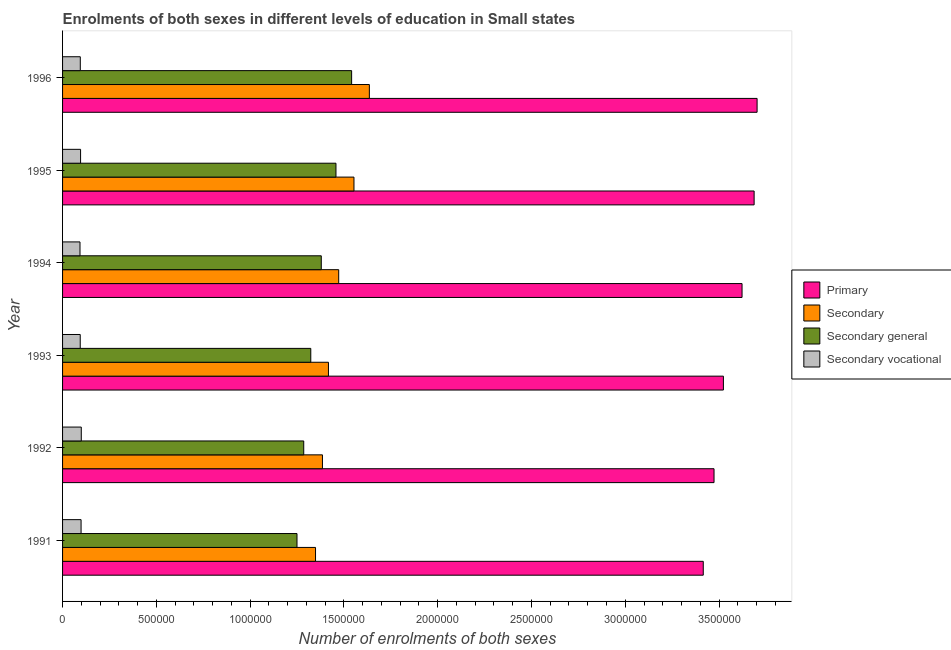How many groups of bars are there?
Keep it short and to the point. 6. How many bars are there on the 6th tick from the bottom?
Offer a very short reply. 4. What is the label of the 6th group of bars from the top?
Ensure brevity in your answer.  1991. What is the number of enrolments in secondary education in 1994?
Provide a short and direct response. 1.47e+06. Across all years, what is the maximum number of enrolments in secondary vocational education?
Provide a succinct answer. 9.98e+04. Across all years, what is the minimum number of enrolments in secondary vocational education?
Provide a short and direct response. 9.29e+04. In which year was the number of enrolments in secondary education maximum?
Keep it short and to the point. 1996. In which year was the number of enrolments in secondary vocational education minimum?
Your answer should be very brief. 1994. What is the total number of enrolments in secondary general education in the graph?
Offer a terse response. 8.24e+06. What is the difference between the number of enrolments in secondary vocational education in 1991 and that in 1992?
Keep it short and to the point. -1069.15. What is the difference between the number of enrolments in secondary general education in 1991 and the number of enrolments in secondary vocational education in 1996?
Give a very brief answer. 1.16e+06. What is the average number of enrolments in secondary education per year?
Ensure brevity in your answer.  1.47e+06. In the year 1994, what is the difference between the number of enrolments in secondary education and number of enrolments in secondary general education?
Offer a terse response. 9.29e+04. What is the ratio of the number of enrolments in secondary education in 1993 to that in 1994?
Offer a very short reply. 0.96. What is the difference between the highest and the second highest number of enrolments in primary education?
Make the answer very short. 1.58e+04. What is the difference between the highest and the lowest number of enrolments in secondary general education?
Your response must be concise. 2.91e+05. What does the 2nd bar from the top in 1991 represents?
Give a very brief answer. Secondary general. What does the 2nd bar from the bottom in 1996 represents?
Provide a short and direct response. Secondary. Is it the case that in every year, the sum of the number of enrolments in primary education and number of enrolments in secondary education is greater than the number of enrolments in secondary general education?
Provide a succinct answer. Yes. How many bars are there?
Provide a short and direct response. 24. How many years are there in the graph?
Provide a succinct answer. 6. Are the values on the major ticks of X-axis written in scientific E-notation?
Offer a very short reply. No. Does the graph contain grids?
Your answer should be very brief. No. Where does the legend appear in the graph?
Offer a terse response. Center right. How many legend labels are there?
Make the answer very short. 4. What is the title of the graph?
Provide a short and direct response. Enrolments of both sexes in different levels of education in Small states. Does "Primary schools" appear as one of the legend labels in the graph?
Offer a very short reply. No. What is the label or title of the X-axis?
Offer a very short reply. Number of enrolments of both sexes. What is the Number of enrolments of both sexes of Primary in 1991?
Ensure brevity in your answer.  3.42e+06. What is the Number of enrolments of both sexes of Secondary in 1991?
Give a very brief answer. 1.35e+06. What is the Number of enrolments of both sexes in Secondary general in 1991?
Keep it short and to the point. 1.25e+06. What is the Number of enrolments of both sexes in Secondary vocational in 1991?
Provide a succinct answer. 9.87e+04. What is the Number of enrolments of both sexes of Primary in 1992?
Your answer should be compact. 3.47e+06. What is the Number of enrolments of both sexes in Secondary in 1992?
Offer a terse response. 1.39e+06. What is the Number of enrolments of both sexes in Secondary general in 1992?
Your response must be concise. 1.29e+06. What is the Number of enrolments of both sexes in Secondary vocational in 1992?
Your answer should be compact. 9.98e+04. What is the Number of enrolments of both sexes of Primary in 1993?
Provide a succinct answer. 3.52e+06. What is the Number of enrolments of both sexes in Secondary in 1993?
Your answer should be compact. 1.42e+06. What is the Number of enrolments of both sexes of Secondary general in 1993?
Give a very brief answer. 1.32e+06. What is the Number of enrolments of both sexes in Secondary vocational in 1993?
Offer a very short reply. 9.42e+04. What is the Number of enrolments of both sexes in Primary in 1994?
Keep it short and to the point. 3.62e+06. What is the Number of enrolments of both sexes in Secondary in 1994?
Offer a terse response. 1.47e+06. What is the Number of enrolments of both sexes in Secondary general in 1994?
Provide a succinct answer. 1.38e+06. What is the Number of enrolments of both sexes in Secondary vocational in 1994?
Offer a terse response. 9.29e+04. What is the Number of enrolments of both sexes in Primary in 1995?
Give a very brief answer. 3.69e+06. What is the Number of enrolments of both sexes in Secondary in 1995?
Provide a short and direct response. 1.55e+06. What is the Number of enrolments of both sexes in Secondary general in 1995?
Make the answer very short. 1.46e+06. What is the Number of enrolments of both sexes in Secondary vocational in 1995?
Your answer should be very brief. 9.60e+04. What is the Number of enrolments of both sexes in Primary in 1996?
Offer a terse response. 3.70e+06. What is the Number of enrolments of both sexes in Secondary in 1996?
Give a very brief answer. 1.64e+06. What is the Number of enrolments of both sexes in Secondary general in 1996?
Ensure brevity in your answer.  1.54e+06. What is the Number of enrolments of both sexes of Secondary vocational in 1996?
Offer a very short reply. 9.46e+04. Across all years, what is the maximum Number of enrolments of both sexes of Primary?
Offer a very short reply. 3.70e+06. Across all years, what is the maximum Number of enrolments of both sexes in Secondary?
Your answer should be very brief. 1.64e+06. Across all years, what is the maximum Number of enrolments of both sexes in Secondary general?
Provide a short and direct response. 1.54e+06. Across all years, what is the maximum Number of enrolments of both sexes in Secondary vocational?
Your answer should be compact. 9.98e+04. Across all years, what is the minimum Number of enrolments of both sexes of Primary?
Your answer should be compact. 3.42e+06. Across all years, what is the minimum Number of enrolments of both sexes in Secondary?
Make the answer very short. 1.35e+06. Across all years, what is the minimum Number of enrolments of both sexes in Secondary general?
Ensure brevity in your answer.  1.25e+06. Across all years, what is the minimum Number of enrolments of both sexes of Secondary vocational?
Offer a very short reply. 9.29e+04. What is the total Number of enrolments of both sexes of Primary in the graph?
Keep it short and to the point. 2.14e+07. What is the total Number of enrolments of both sexes in Secondary in the graph?
Provide a short and direct response. 8.81e+06. What is the total Number of enrolments of both sexes in Secondary general in the graph?
Your response must be concise. 8.24e+06. What is the total Number of enrolments of both sexes of Secondary vocational in the graph?
Offer a very short reply. 5.76e+05. What is the difference between the Number of enrolments of both sexes of Primary in 1991 and that in 1992?
Provide a succinct answer. -5.74e+04. What is the difference between the Number of enrolments of both sexes of Secondary in 1991 and that in 1992?
Make the answer very short. -3.69e+04. What is the difference between the Number of enrolments of both sexes in Secondary general in 1991 and that in 1992?
Offer a terse response. -3.58e+04. What is the difference between the Number of enrolments of both sexes in Secondary vocational in 1991 and that in 1992?
Offer a very short reply. -1069.15. What is the difference between the Number of enrolments of both sexes in Primary in 1991 and that in 1993?
Offer a terse response. -1.07e+05. What is the difference between the Number of enrolments of both sexes of Secondary in 1991 and that in 1993?
Make the answer very short. -6.90e+04. What is the difference between the Number of enrolments of both sexes of Secondary general in 1991 and that in 1993?
Offer a very short reply. -7.35e+04. What is the difference between the Number of enrolments of both sexes in Secondary vocational in 1991 and that in 1993?
Offer a very short reply. 4531.68. What is the difference between the Number of enrolments of both sexes in Primary in 1991 and that in 1994?
Offer a terse response. -2.07e+05. What is the difference between the Number of enrolments of both sexes of Secondary in 1991 and that in 1994?
Your answer should be compact. -1.24e+05. What is the difference between the Number of enrolments of both sexes of Secondary general in 1991 and that in 1994?
Your answer should be very brief. -1.29e+05. What is the difference between the Number of enrolments of both sexes in Secondary vocational in 1991 and that in 1994?
Offer a terse response. 5820.7. What is the difference between the Number of enrolments of both sexes in Primary in 1991 and that in 1995?
Give a very brief answer. -2.71e+05. What is the difference between the Number of enrolments of both sexes of Secondary in 1991 and that in 1995?
Your response must be concise. -2.05e+05. What is the difference between the Number of enrolments of both sexes of Secondary general in 1991 and that in 1995?
Your answer should be very brief. -2.08e+05. What is the difference between the Number of enrolments of both sexes of Secondary vocational in 1991 and that in 1995?
Offer a terse response. 2729.91. What is the difference between the Number of enrolments of both sexes of Primary in 1991 and that in 1996?
Provide a succinct answer. -2.87e+05. What is the difference between the Number of enrolments of both sexes in Secondary in 1991 and that in 1996?
Give a very brief answer. -2.87e+05. What is the difference between the Number of enrolments of both sexes of Secondary general in 1991 and that in 1996?
Your answer should be compact. -2.91e+05. What is the difference between the Number of enrolments of both sexes in Secondary vocational in 1991 and that in 1996?
Your response must be concise. 4179.59. What is the difference between the Number of enrolments of both sexes of Primary in 1992 and that in 1993?
Your answer should be compact. -5.00e+04. What is the difference between the Number of enrolments of both sexes of Secondary in 1992 and that in 1993?
Offer a very short reply. -3.20e+04. What is the difference between the Number of enrolments of both sexes in Secondary general in 1992 and that in 1993?
Make the answer very short. -3.76e+04. What is the difference between the Number of enrolments of both sexes of Secondary vocational in 1992 and that in 1993?
Your answer should be compact. 5600.83. What is the difference between the Number of enrolments of both sexes in Primary in 1992 and that in 1994?
Your answer should be compact. -1.49e+05. What is the difference between the Number of enrolments of both sexes in Secondary in 1992 and that in 1994?
Offer a terse response. -8.66e+04. What is the difference between the Number of enrolments of both sexes of Secondary general in 1992 and that in 1994?
Your answer should be compact. -9.35e+04. What is the difference between the Number of enrolments of both sexes in Secondary vocational in 1992 and that in 1994?
Your answer should be very brief. 6889.84. What is the difference between the Number of enrolments of both sexes of Primary in 1992 and that in 1995?
Your answer should be compact. -2.14e+05. What is the difference between the Number of enrolments of both sexes in Secondary in 1992 and that in 1995?
Your answer should be very brief. -1.68e+05. What is the difference between the Number of enrolments of both sexes of Secondary general in 1992 and that in 1995?
Provide a short and direct response. -1.72e+05. What is the difference between the Number of enrolments of both sexes in Secondary vocational in 1992 and that in 1995?
Provide a short and direct response. 3799.05. What is the difference between the Number of enrolments of both sexes in Primary in 1992 and that in 1996?
Give a very brief answer. -2.30e+05. What is the difference between the Number of enrolments of both sexes in Secondary in 1992 and that in 1996?
Your answer should be very brief. -2.50e+05. What is the difference between the Number of enrolments of both sexes in Secondary general in 1992 and that in 1996?
Ensure brevity in your answer.  -2.55e+05. What is the difference between the Number of enrolments of both sexes of Secondary vocational in 1992 and that in 1996?
Your answer should be very brief. 5248.73. What is the difference between the Number of enrolments of both sexes of Primary in 1993 and that in 1994?
Ensure brevity in your answer.  -9.95e+04. What is the difference between the Number of enrolments of both sexes in Secondary in 1993 and that in 1994?
Your answer should be very brief. -5.46e+04. What is the difference between the Number of enrolments of both sexes of Secondary general in 1993 and that in 1994?
Make the answer very short. -5.59e+04. What is the difference between the Number of enrolments of both sexes of Secondary vocational in 1993 and that in 1994?
Your response must be concise. 1289.02. What is the difference between the Number of enrolments of both sexes of Primary in 1993 and that in 1995?
Your answer should be very brief. -1.64e+05. What is the difference between the Number of enrolments of both sexes in Secondary in 1993 and that in 1995?
Your answer should be very brief. -1.36e+05. What is the difference between the Number of enrolments of both sexes in Secondary general in 1993 and that in 1995?
Your answer should be compact. -1.34e+05. What is the difference between the Number of enrolments of both sexes of Secondary vocational in 1993 and that in 1995?
Provide a succinct answer. -1801.77. What is the difference between the Number of enrolments of both sexes in Primary in 1993 and that in 1996?
Offer a very short reply. -1.80e+05. What is the difference between the Number of enrolments of both sexes of Secondary in 1993 and that in 1996?
Ensure brevity in your answer.  -2.18e+05. What is the difference between the Number of enrolments of both sexes in Secondary general in 1993 and that in 1996?
Provide a succinct answer. -2.18e+05. What is the difference between the Number of enrolments of both sexes in Secondary vocational in 1993 and that in 1996?
Your answer should be compact. -352.09. What is the difference between the Number of enrolments of both sexes in Primary in 1994 and that in 1995?
Offer a very short reply. -6.44e+04. What is the difference between the Number of enrolments of both sexes in Secondary in 1994 and that in 1995?
Your answer should be compact. -8.14e+04. What is the difference between the Number of enrolments of both sexes in Secondary general in 1994 and that in 1995?
Provide a succinct answer. -7.83e+04. What is the difference between the Number of enrolments of both sexes in Secondary vocational in 1994 and that in 1995?
Offer a very short reply. -3090.79. What is the difference between the Number of enrolments of both sexes in Primary in 1994 and that in 1996?
Make the answer very short. -8.02e+04. What is the difference between the Number of enrolments of both sexes of Secondary in 1994 and that in 1996?
Make the answer very short. -1.63e+05. What is the difference between the Number of enrolments of both sexes of Secondary general in 1994 and that in 1996?
Make the answer very short. -1.62e+05. What is the difference between the Number of enrolments of both sexes in Secondary vocational in 1994 and that in 1996?
Offer a terse response. -1641.11. What is the difference between the Number of enrolments of both sexes of Primary in 1995 and that in 1996?
Offer a very short reply. -1.58e+04. What is the difference between the Number of enrolments of both sexes of Secondary in 1995 and that in 1996?
Offer a terse response. -8.21e+04. What is the difference between the Number of enrolments of both sexes in Secondary general in 1995 and that in 1996?
Offer a very short reply. -8.35e+04. What is the difference between the Number of enrolments of both sexes of Secondary vocational in 1995 and that in 1996?
Offer a terse response. 1449.68. What is the difference between the Number of enrolments of both sexes in Primary in 1991 and the Number of enrolments of both sexes in Secondary in 1992?
Keep it short and to the point. 2.03e+06. What is the difference between the Number of enrolments of both sexes in Primary in 1991 and the Number of enrolments of both sexes in Secondary general in 1992?
Offer a very short reply. 2.13e+06. What is the difference between the Number of enrolments of both sexes in Primary in 1991 and the Number of enrolments of both sexes in Secondary vocational in 1992?
Provide a short and direct response. 3.32e+06. What is the difference between the Number of enrolments of both sexes of Secondary in 1991 and the Number of enrolments of both sexes of Secondary general in 1992?
Offer a very short reply. 6.29e+04. What is the difference between the Number of enrolments of both sexes in Secondary in 1991 and the Number of enrolments of both sexes in Secondary vocational in 1992?
Provide a short and direct response. 1.25e+06. What is the difference between the Number of enrolments of both sexes of Secondary general in 1991 and the Number of enrolments of both sexes of Secondary vocational in 1992?
Your answer should be compact. 1.15e+06. What is the difference between the Number of enrolments of both sexes of Primary in 1991 and the Number of enrolments of both sexes of Secondary in 1993?
Your answer should be very brief. 2.00e+06. What is the difference between the Number of enrolments of both sexes of Primary in 1991 and the Number of enrolments of both sexes of Secondary general in 1993?
Offer a very short reply. 2.09e+06. What is the difference between the Number of enrolments of both sexes in Primary in 1991 and the Number of enrolments of both sexes in Secondary vocational in 1993?
Keep it short and to the point. 3.32e+06. What is the difference between the Number of enrolments of both sexes of Secondary in 1991 and the Number of enrolments of both sexes of Secondary general in 1993?
Keep it short and to the point. 2.53e+04. What is the difference between the Number of enrolments of both sexes of Secondary in 1991 and the Number of enrolments of both sexes of Secondary vocational in 1993?
Offer a very short reply. 1.25e+06. What is the difference between the Number of enrolments of both sexes in Secondary general in 1991 and the Number of enrolments of both sexes in Secondary vocational in 1993?
Offer a terse response. 1.16e+06. What is the difference between the Number of enrolments of both sexes in Primary in 1991 and the Number of enrolments of both sexes in Secondary in 1994?
Your answer should be very brief. 1.94e+06. What is the difference between the Number of enrolments of both sexes of Primary in 1991 and the Number of enrolments of both sexes of Secondary general in 1994?
Ensure brevity in your answer.  2.04e+06. What is the difference between the Number of enrolments of both sexes in Primary in 1991 and the Number of enrolments of both sexes in Secondary vocational in 1994?
Your response must be concise. 3.32e+06. What is the difference between the Number of enrolments of both sexes in Secondary in 1991 and the Number of enrolments of both sexes in Secondary general in 1994?
Provide a short and direct response. -3.07e+04. What is the difference between the Number of enrolments of both sexes in Secondary in 1991 and the Number of enrolments of both sexes in Secondary vocational in 1994?
Offer a terse response. 1.26e+06. What is the difference between the Number of enrolments of both sexes of Secondary general in 1991 and the Number of enrolments of both sexes of Secondary vocational in 1994?
Your answer should be very brief. 1.16e+06. What is the difference between the Number of enrolments of both sexes in Primary in 1991 and the Number of enrolments of both sexes in Secondary in 1995?
Ensure brevity in your answer.  1.86e+06. What is the difference between the Number of enrolments of both sexes of Primary in 1991 and the Number of enrolments of both sexes of Secondary general in 1995?
Make the answer very short. 1.96e+06. What is the difference between the Number of enrolments of both sexes of Primary in 1991 and the Number of enrolments of both sexes of Secondary vocational in 1995?
Provide a succinct answer. 3.32e+06. What is the difference between the Number of enrolments of both sexes in Secondary in 1991 and the Number of enrolments of both sexes in Secondary general in 1995?
Provide a succinct answer. -1.09e+05. What is the difference between the Number of enrolments of both sexes of Secondary in 1991 and the Number of enrolments of both sexes of Secondary vocational in 1995?
Give a very brief answer. 1.25e+06. What is the difference between the Number of enrolments of both sexes of Secondary general in 1991 and the Number of enrolments of both sexes of Secondary vocational in 1995?
Ensure brevity in your answer.  1.15e+06. What is the difference between the Number of enrolments of both sexes of Primary in 1991 and the Number of enrolments of both sexes of Secondary in 1996?
Your answer should be compact. 1.78e+06. What is the difference between the Number of enrolments of both sexes of Primary in 1991 and the Number of enrolments of both sexes of Secondary general in 1996?
Your answer should be compact. 1.87e+06. What is the difference between the Number of enrolments of both sexes of Primary in 1991 and the Number of enrolments of both sexes of Secondary vocational in 1996?
Give a very brief answer. 3.32e+06. What is the difference between the Number of enrolments of both sexes of Secondary in 1991 and the Number of enrolments of both sexes of Secondary general in 1996?
Keep it short and to the point. -1.92e+05. What is the difference between the Number of enrolments of both sexes in Secondary in 1991 and the Number of enrolments of both sexes in Secondary vocational in 1996?
Offer a terse response. 1.25e+06. What is the difference between the Number of enrolments of both sexes of Secondary general in 1991 and the Number of enrolments of both sexes of Secondary vocational in 1996?
Offer a terse response. 1.16e+06. What is the difference between the Number of enrolments of both sexes in Primary in 1992 and the Number of enrolments of both sexes in Secondary in 1993?
Your answer should be very brief. 2.06e+06. What is the difference between the Number of enrolments of both sexes in Primary in 1992 and the Number of enrolments of both sexes in Secondary general in 1993?
Provide a succinct answer. 2.15e+06. What is the difference between the Number of enrolments of both sexes in Primary in 1992 and the Number of enrolments of both sexes in Secondary vocational in 1993?
Your answer should be compact. 3.38e+06. What is the difference between the Number of enrolments of both sexes of Secondary in 1992 and the Number of enrolments of both sexes of Secondary general in 1993?
Your answer should be compact. 6.22e+04. What is the difference between the Number of enrolments of both sexes in Secondary in 1992 and the Number of enrolments of both sexes in Secondary vocational in 1993?
Make the answer very short. 1.29e+06. What is the difference between the Number of enrolments of both sexes of Secondary general in 1992 and the Number of enrolments of both sexes of Secondary vocational in 1993?
Ensure brevity in your answer.  1.19e+06. What is the difference between the Number of enrolments of both sexes in Primary in 1992 and the Number of enrolments of both sexes in Secondary in 1994?
Give a very brief answer. 2.00e+06. What is the difference between the Number of enrolments of both sexes in Primary in 1992 and the Number of enrolments of both sexes in Secondary general in 1994?
Your response must be concise. 2.09e+06. What is the difference between the Number of enrolments of both sexes in Primary in 1992 and the Number of enrolments of both sexes in Secondary vocational in 1994?
Keep it short and to the point. 3.38e+06. What is the difference between the Number of enrolments of both sexes in Secondary in 1992 and the Number of enrolments of both sexes in Secondary general in 1994?
Your answer should be compact. 6265.5. What is the difference between the Number of enrolments of both sexes of Secondary in 1992 and the Number of enrolments of both sexes of Secondary vocational in 1994?
Make the answer very short. 1.29e+06. What is the difference between the Number of enrolments of both sexes of Secondary general in 1992 and the Number of enrolments of both sexes of Secondary vocational in 1994?
Keep it short and to the point. 1.19e+06. What is the difference between the Number of enrolments of both sexes in Primary in 1992 and the Number of enrolments of both sexes in Secondary in 1995?
Offer a very short reply. 1.92e+06. What is the difference between the Number of enrolments of both sexes of Primary in 1992 and the Number of enrolments of both sexes of Secondary general in 1995?
Your response must be concise. 2.02e+06. What is the difference between the Number of enrolments of both sexes in Primary in 1992 and the Number of enrolments of both sexes in Secondary vocational in 1995?
Offer a very short reply. 3.38e+06. What is the difference between the Number of enrolments of both sexes in Secondary in 1992 and the Number of enrolments of both sexes in Secondary general in 1995?
Offer a very short reply. -7.20e+04. What is the difference between the Number of enrolments of both sexes of Secondary in 1992 and the Number of enrolments of both sexes of Secondary vocational in 1995?
Provide a succinct answer. 1.29e+06. What is the difference between the Number of enrolments of both sexes of Secondary general in 1992 and the Number of enrolments of both sexes of Secondary vocational in 1995?
Give a very brief answer. 1.19e+06. What is the difference between the Number of enrolments of both sexes of Primary in 1992 and the Number of enrolments of both sexes of Secondary in 1996?
Your response must be concise. 1.84e+06. What is the difference between the Number of enrolments of both sexes of Primary in 1992 and the Number of enrolments of both sexes of Secondary general in 1996?
Your response must be concise. 1.93e+06. What is the difference between the Number of enrolments of both sexes in Primary in 1992 and the Number of enrolments of both sexes in Secondary vocational in 1996?
Offer a very short reply. 3.38e+06. What is the difference between the Number of enrolments of both sexes of Secondary in 1992 and the Number of enrolments of both sexes of Secondary general in 1996?
Provide a succinct answer. -1.56e+05. What is the difference between the Number of enrolments of both sexes of Secondary in 1992 and the Number of enrolments of both sexes of Secondary vocational in 1996?
Your response must be concise. 1.29e+06. What is the difference between the Number of enrolments of both sexes of Secondary general in 1992 and the Number of enrolments of both sexes of Secondary vocational in 1996?
Your response must be concise. 1.19e+06. What is the difference between the Number of enrolments of both sexes in Primary in 1993 and the Number of enrolments of both sexes in Secondary in 1994?
Ensure brevity in your answer.  2.05e+06. What is the difference between the Number of enrolments of both sexes in Primary in 1993 and the Number of enrolments of both sexes in Secondary general in 1994?
Your answer should be very brief. 2.14e+06. What is the difference between the Number of enrolments of both sexes of Primary in 1993 and the Number of enrolments of both sexes of Secondary vocational in 1994?
Keep it short and to the point. 3.43e+06. What is the difference between the Number of enrolments of both sexes in Secondary in 1993 and the Number of enrolments of both sexes in Secondary general in 1994?
Your response must be concise. 3.83e+04. What is the difference between the Number of enrolments of both sexes of Secondary in 1993 and the Number of enrolments of both sexes of Secondary vocational in 1994?
Give a very brief answer. 1.32e+06. What is the difference between the Number of enrolments of both sexes of Secondary general in 1993 and the Number of enrolments of both sexes of Secondary vocational in 1994?
Give a very brief answer. 1.23e+06. What is the difference between the Number of enrolments of both sexes of Primary in 1993 and the Number of enrolments of both sexes of Secondary in 1995?
Ensure brevity in your answer.  1.97e+06. What is the difference between the Number of enrolments of both sexes of Primary in 1993 and the Number of enrolments of both sexes of Secondary general in 1995?
Keep it short and to the point. 2.07e+06. What is the difference between the Number of enrolments of both sexes in Primary in 1993 and the Number of enrolments of both sexes in Secondary vocational in 1995?
Your answer should be very brief. 3.43e+06. What is the difference between the Number of enrolments of both sexes in Secondary in 1993 and the Number of enrolments of both sexes in Secondary general in 1995?
Offer a terse response. -4.00e+04. What is the difference between the Number of enrolments of both sexes in Secondary in 1993 and the Number of enrolments of both sexes in Secondary vocational in 1995?
Offer a very short reply. 1.32e+06. What is the difference between the Number of enrolments of both sexes in Secondary general in 1993 and the Number of enrolments of both sexes in Secondary vocational in 1995?
Provide a short and direct response. 1.23e+06. What is the difference between the Number of enrolments of both sexes of Primary in 1993 and the Number of enrolments of both sexes of Secondary in 1996?
Your response must be concise. 1.89e+06. What is the difference between the Number of enrolments of both sexes in Primary in 1993 and the Number of enrolments of both sexes in Secondary general in 1996?
Keep it short and to the point. 1.98e+06. What is the difference between the Number of enrolments of both sexes in Primary in 1993 and the Number of enrolments of both sexes in Secondary vocational in 1996?
Ensure brevity in your answer.  3.43e+06. What is the difference between the Number of enrolments of both sexes of Secondary in 1993 and the Number of enrolments of both sexes of Secondary general in 1996?
Offer a very short reply. -1.24e+05. What is the difference between the Number of enrolments of both sexes of Secondary in 1993 and the Number of enrolments of both sexes of Secondary vocational in 1996?
Offer a terse response. 1.32e+06. What is the difference between the Number of enrolments of both sexes of Secondary general in 1993 and the Number of enrolments of both sexes of Secondary vocational in 1996?
Offer a very short reply. 1.23e+06. What is the difference between the Number of enrolments of both sexes in Primary in 1994 and the Number of enrolments of both sexes in Secondary in 1995?
Ensure brevity in your answer.  2.07e+06. What is the difference between the Number of enrolments of both sexes of Primary in 1994 and the Number of enrolments of both sexes of Secondary general in 1995?
Make the answer very short. 2.17e+06. What is the difference between the Number of enrolments of both sexes in Primary in 1994 and the Number of enrolments of both sexes in Secondary vocational in 1995?
Provide a short and direct response. 3.53e+06. What is the difference between the Number of enrolments of both sexes of Secondary in 1994 and the Number of enrolments of both sexes of Secondary general in 1995?
Your response must be concise. 1.46e+04. What is the difference between the Number of enrolments of both sexes in Secondary in 1994 and the Number of enrolments of both sexes in Secondary vocational in 1995?
Your response must be concise. 1.38e+06. What is the difference between the Number of enrolments of both sexes in Secondary general in 1994 and the Number of enrolments of both sexes in Secondary vocational in 1995?
Offer a terse response. 1.28e+06. What is the difference between the Number of enrolments of both sexes of Primary in 1994 and the Number of enrolments of both sexes of Secondary in 1996?
Offer a terse response. 1.99e+06. What is the difference between the Number of enrolments of both sexes of Primary in 1994 and the Number of enrolments of both sexes of Secondary general in 1996?
Make the answer very short. 2.08e+06. What is the difference between the Number of enrolments of both sexes in Primary in 1994 and the Number of enrolments of both sexes in Secondary vocational in 1996?
Your response must be concise. 3.53e+06. What is the difference between the Number of enrolments of both sexes in Secondary in 1994 and the Number of enrolments of both sexes in Secondary general in 1996?
Your response must be concise. -6.89e+04. What is the difference between the Number of enrolments of both sexes of Secondary in 1994 and the Number of enrolments of both sexes of Secondary vocational in 1996?
Keep it short and to the point. 1.38e+06. What is the difference between the Number of enrolments of both sexes of Secondary general in 1994 and the Number of enrolments of both sexes of Secondary vocational in 1996?
Give a very brief answer. 1.28e+06. What is the difference between the Number of enrolments of both sexes in Primary in 1995 and the Number of enrolments of both sexes in Secondary in 1996?
Your response must be concise. 2.05e+06. What is the difference between the Number of enrolments of both sexes of Primary in 1995 and the Number of enrolments of both sexes of Secondary general in 1996?
Your response must be concise. 2.15e+06. What is the difference between the Number of enrolments of both sexes of Primary in 1995 and the Number of enrolments of both sexes of Secondary vocational in 1996?
Offer a terse response. 3.59e+06. What is the difference between the Number of enrolments of both sexes in Secondary in 1995 and the Number of enrolments of both sexes in Secondary general in 1996?
Offer a very short reply. 1.25e+04. What is the difference between the Number of enrolments of both sexes of Secondary in 1995 and the Number of enrolments of both sexes of Secondary vocational in 1996?
Provide a succinct answer. 1.46e+06. What is the difference between the Number of enrolments of both sexes of Secondary general in 1995 and the Number of enrolments of both sexes of Secondary vocational in 1996?
Offer a very short reply. 1.36e+06. What is the average Number of enrolments of both sexes of Primary per year?
Your answer should be compact. 3.57e+06. What is the average Number of enrolments of both sexes of Secondary per year?
Keep it short and to the point. 1.47e+06. What is the average Number of enrolments of both sexes in Secondary general per year?
Your response must be concise. 1.37e+06. What is the average Number of enrolments of both sexes of Secondary vocational per year?
Offer a terse response. 9.60e+04. In the year 1991, what is the difference between the Number of enrolments of both sexes of Primary and Number of enrolments of both sexes of Secondary?
Provide a short and direct response. 2.07e+06. In the year 1991, what is the difference between the Number of enrolments of both sexes in Primary and Number of enrolments of both sexes in Secondary general?
Your answer should be compact. 2.17e+06. In the year 1991, what is the difference between the Number of enrolments of both sexes of Primary and Number of enrolments of both sexes of Secondary vocational?
Provide a succinct answer. 3.32e+06. In the year 1991, what is the difference between the Number of enrolments of both sexes of Secondary and Number of enrolments of both sexes of Secondary general?
Provide a succinct answer. 9.87e+04. In the year 1991, what is the difference between the Number of enrolments of both sexes of Secondary and Number of enrolments of both sexes of Secondary vocational?
Make the answer very short. 1.25e+06. In the year 1991, what is the difference between the Number of enrolments of both sexes of Secondary general and Number of enrolments of both sexes of Secondary vocational?
Provide a short and direct response. 1.15e+06. In the year 1992, what is the difference between the Number of enrolments of both sexes in Primary and Number of enrolments of both sexes in Secondary?
Make the answer very short. 2.09e+06. In the year 1992, what is the difference between the Number of enrolments of both sexes of Primary and Number of enrolments of both sexes of Secondary general?
Ensure brevity in your answer.  2.19e+06. In the year 1992, what is the difference between the Number of enrolments of both sexes of Primary and Number of enrolments of both sexes of Secondary vocational?
Make the answer very short. 3.37e+06. In the year 1992, what is the difference between the Number of enrolments of both sexes in Secondary and Number of enrolments of both sexes in Secondary general?
Give a very brief answer. 9.98e+04. In the year 1992, what is the difference between the Number of enrolments of both sexes of Secondary and Number of enrolments of both sexes of Secondary vocational?
Your response must be concise. 1.29e+06. In the year 1992, what is the difference between the Number of enrolments of both sexes in Secondary general and Number of enrolments of both sexes in Secondary vocational?
Your answer should be very brief. 1.19e+06. In the year 1993, what is the difference between the Number of enrolments of both sexes in Primary and Number of enrolments of both sexes in Secondary?
Keep it short and to the point. 2.11e+06. In the year 1993, what is the difference between the Number of enrolments of both sexes of Primary and Number of enrolments of both sexes of Secondary general?
Offer a very short reply. 2.20e+06. In the year 1993, what is the difference between the Number of enrolments of both sexes in Primary and Number of enrolments of both sexes in Secondary vocational?
Your answer should be very brief. 3.43e+06. In the year 1993, what is the difference between the Number of enrolments of both sexes in Secondary and Number of enrolments of both sexes in Secondary general?
Your answer should be compact. 9.42e+04. In the year 1993, what is the difference between the Number of enrolments of both sexes of Secondary and Number of enrolments of both sexes of Secondary vocational?
Your answer should be compact. 1.32e+06. In the year 1993, what is the difference between the Number of enrolments of both sexes of Secondary general and Number of enrolments of both sexes of Secondary vocational?
Offer a very short reply. 1.23e+06. In the year 1994, what is the difference between the Number of enrolments of both sexes of Primary and Number of enrolments of both sexes of Secondary?
Your answer should be compact. 2.15e+06. In the year 1994, what is the difference between the Number of enrolments of both sexes of Primary and Number of enrolments of both sexes of Secondary general?
Your response must be concise. 2.24e+06. In the year 1994, what is the difference between the Number of enrolments of both sexes in Primary and Number of enrolments of both sexes in Secondary vocational?
Your answer should be very brief. 3.53e+06. In the year 1994, what is the difference between the Number of enrolments of both sexes in Secondary and Number of enrolments of both sexes in Secondary general?
Make the answer very short. 9.29e+04. In the year 1994, what is the difference between the Number of enrolments of both sexes in Secondary and Number of enrolments of both sexes in Secondary vocational?
Provide a succinct answer. 1.38e+06. In the year 1994, what is the difference between the Number of enrolments of both sexes in Secondary general and Number of enrolments of both sexes in Secondary vocational?
Keep it short and to the point. 1.29e+06. In the year 1995, what is the difference between the Number of enrolments of both sexes in Primary and Number of enrolments of both sexes in Secondary?
Make the answer very short. 2.13e+06. In the year 1995, what is the difference between the Number of enrolments of both sexes in Primary and Number of enrolments of both sexes in Secondary general?
Your answer should be very brief. 2.23e+06. In the year 1995, what is the difference between the Number of enrolments of both sexes in Primary and Number of enrolments of both sexes in Secondary vocational?
Your response must be concise. 3.59e+06. In the year 1995, what is the difference between the Number of enrolments of both sexes of Secondary and Number of enrolments of both sexes of Secondary general?
Provide a short and direct response. 9.60e+04. In the year 1995, what is the difference between the Number of enrolments of both sexes of Secondary and Number of enrolments of both sexes of Secondary vocational?
Your answer should be very brief. 1.46e+06. In the year 1995, what is the difference between the Number of enrolments of both sexes of Secondary general and Number of enrolments of both sexes of Secondary vocational?
Offer a terse response. 1.36e+06. In the year 1996, what is the difference between the Number of enrolments of both sexes of Primary and Number of enrolments of both sexes of Secondary?
Provide a short and direct response. 2.07e+06. In the year 1996, what is the difference between the Number of enrolments of both sexes of Primary and Number of enrolments of both sexes of Secondary general?
Provide a succinct answer. 2.16e+06. In the year 1996, what is the difference between the Number of enrolments of both sexes of Primary and Number of enrolments of both sexes of Secondary vocational?
Your answer should be compact. 3.61e+06. In the year 1996, what is the difference between the Number of enrolments of both sexes in Secondary and Number of enrolments of both sexes in Secondary general?
Your response must be concise. 9.46e+04. In the year 1996, what is the difference between the Number of enrolments of both sexes in Secondary and Number of enrolments of both sexes in Secondary vocational?
Provide a short and direct response. 1.54e+06. In the year 1996, what is the difference between the Number of enrolments of both sexes of Secondary general and Number of enrolments of both sexes of Secondary vocational?
Your answer should be very brief. 1.45e+06. What is the ratio of the Number of enrolments of both sexes of Primary in 1991 to that in 1992?
Offer a very short reply. 0.98. What is the ratio of the Number of enrolments of both sexes of Secondary in 1991 to that in 1992?
Provide a short and direct response. 0.97. What is the ratio of the Number of enrolments of both sexes of Secondary general in 1991 to that in 1992?
Offer a terse response. 0.97. What is the ratio of the Number of enrolments of both sexes in Secondary vocational in 1991 to that in 1992?
Your answer should be compact. 0.99. What is the ratio of the Number of enrolments of both sexes of Primary in 1991 to that in 1993?
Your response must be concise. 0.97. What is the ratio of the Number of enrolments of both sexes in Secondary in 1991 to that in 1993?
Offer a very short reply. 0.95. What is the ratio of the Number of enrolments of both sexes of Secondary general in 1991 to that in 1993?
Ensure brevity in your answer.  0.94. What is the ratio of the Number of enrolments of both sexes of Secondary vocational in 1991 to that in 1993?
Your answer should be compact. 1.05. What is the ratio of the Number of enrolments of both sexes of Primary in 1991 to that in 1994?
Offer a terse response. 0.94. What is the ratio of the Number of enrolments of both sexes of Secondary in 1991 to that in 1994?
Provide a short and direct response. 0.92. What is the ratio of the Number of enrolments of both sexes in Secondary general in 1991 to that in 1994?
Ensure brevity in your answer.  0.91. What is the ratio of the Number of enrolments of both sexes of Secondary vocational in 1991 to that in 1994?
Ensure brevity in your answer.  1.06. What is the ratio of the Number of enrolments of both sexes in Primary in 1991 to that in 1995?
Offer a very short reply. 0.93. What is the ratio of the Number of enrolments of both sexes in Secondary in 1991 to that in 1995?
Give a very brief answer. 0.87. What is the ratio of the Number of enrolments of both sexes in Secondary general in 1991 to that in 1995?
Your answer should be very brief. 0.86. What is the ratio of the Number of enrolments of both sexes in Secondary vocational in 1991 to that in 1995?
Offer a very short reply. 1.03. What is the ratio of the Number of enrolments of both sexes in Primary in 1991 to that in 1996?
Give a very brief answer. 0.92. What is the ratio of the Number of enrolments of both sexes of Secondary in 1991 to that in 1996?
Your answer should be compact. 0.82. What is the ratio of the Number of enrolments of both sexes in Secondary general in 1991 to that in 1996?
Make the answer very short. 0.81. What is the ratio of the Number of enrolments of both sexes of Secondary vocational in 1991 to that in 1996?
Make the answer very short. 1.04. What is the ratio of the Number of enrolments of both sexes in Primary in 1992 to that in 1993?
Give a very brief answer. 0.99. What is the ratio of the Number of enrolments of both sexes in Secondary in 1992 to that in 1993?
Offer a very short reply. 0.98. What is the ratio of the Number of enrolments of both sexes in Secondary general in 1992 to that in 1993?
Your answer should be very brief. 0.97. What is the ratio of the Number of enrolments of both sexes in Secondary vocational in 1992 to that in 1993?
Your answer should be very brief. 1.06. What is the ratio of the Number of enrolments of both sexes of Primary in 1992 to that in 1994?
Offer a very short reply. 0.96. What is the ratio of the Number of enrolments of both sexes in Secondary in 1992 to that in 1994?
Give a very brief answer. 0.94. What is the ratio of the Number of enrolments of both sexes in Secondary general in 1992 to that in 1994?
Your response must be concise. 0.93. What is the ratio of the Number of enrolments of both sexes of Secondary vocational in 1992 to that in 1994?
Ensure brevity in your answer.  1.07. What is the ratio of the Number of enrolments of both sexes of Primary in 1992 to that in 1995?
Your response must be concise. 0.94. What is the ratio of the Number of enrolments of both sexes in Secondary in 1992 to that in 1995?
Ensure brevity in your answer.  0.89. What is the ratio of the Number of enrolments of both sexes of Secondary general in 1992 to that in 1995?
Provide a short and direct response. 0.88. What is the ratio of the Number of enrolments of both sexes of Secondary vocational in 1992 to that in 1995?
Your answer should be very brief. 1.04. What is the ratio of the Number of enrolments of both sexes in Primary in 1992 to that in 1996?
Your answer should be very brief. 0.94. What is the ratio of the Number of enrolments of both sexes in Secondary in 1992 to that in 1996?
Ensure brevity in your answer.  0.85. What is the ratio of the Number of enrolments of both sexes in Secondary general in 1992 to that in 1996?
Provide a succinct answer. 0.83. What is the ratio of the Number of enrolments of both sexes of Secondary vocational in 1992 to that in 1996?
Your answer should be very brief. 1.06. What is the ratio of the Number of enrolments of both sexes in Primary in 1993 to that in 1994?
Provide a succinct answer. 0.97. What is the ratio of the Number of enrolments of both sexes of Secondary in 1993 to that in 1994?
Offer a terse response. 0.96. What is the ratio of the Number of enrolments of both sexes in Secondary general in 1993 to that in 1994?
Make the answer very short. 0.96. What is the ratio of the Number of enrolments of both sexes in Secondary vocational in 1993 to that in 1994?
Provide a succinct answer. 1.01. What is the ratio of the Number of enrolments of both sexes in Primary in 1993 to that in 1995?
Your answer should be very brief. 0.96. What is the ratio of the Number of enrolments of both sexes in Secondary in 1993 to that in 1995?
Your response must be concise. 0.91. What is the ratio of the Number of enrolments of both sexes in Secondary general in 1993 to that in 1995?
Offer a terse response. 0.91. What is the ratio of the Number of enrolments of both sexes in Secondary vocational in 1993 to that in 1995?
Give a very brief answer. 0.98. What is the ratio of the Number of enrolments of both sexes of Primary in 1993 to that in 1996?
Give a very brief answer. 0.95. What is the ratio of the Number of enrolments of both sexes of Secondary in 1993 to that in 1996?
Keep it short and to the point. 0.87. What is the ratio of the Number of enrolments of both sexes in Secondary general in 1993 to that in 1996?
Offer a terse response. 0.86. What is the ratio of the Number of enrolments of both sexes in Primary in 1994 to that in 1995?
Your answer should be very brief. 0.98. What is the ratio of the Number of enrolments of both sexes in Secondary in 1994 to that in 1995?
Give a very brief answer. 0.95. What is the ratio of the Number of enrolments of both sexes in Secondary general in 1994 to that in 1995?
Make the answer very short. 0.95. What is the ratio of the Number of enrolments of both sexes of Secondary vocational in 1994 to that in 1995?
Your answer should be very brief. 0.97. What is the ratio of the Number of enrolments of both sexes in Primary in 1994 to that in 1996?
Make the answer very short. 0.98. What is the ratio of the Number of enrolments of both sexes of Secondary in 1994 to that in 1996?
Provide a short and direct response. 0.9. What is the ratio of the Number of enrolments of both sexes of Secondary general in 1994 to that in 1996?
Keep it short and to the point. 0.9. What is the ratio of the Number of enrolments of both sexes of Secondary vocational in 1994 to that in 1996?
Give a very brief answer. 0.98. What is the ratio of the Number of enrolments of both sexes in Secondary in 1995 to that in 1996?
Make the answer very short. 0.95. What is the ratio of the Number of enrolments of both sexes of Secondary general in 1995 to that in 1996?
Offer a terse response. 0.95. What is the ratio of the Number of enrolments of both sexes in Secondary vocational in 1995 to that in 1996?
Your response must be concise. 1.02. What is the difference between the highest and the second highest Number of enrolments of both sexes of Primary?
Make the answer very short. 1.58e+04. What is the difference between the highest and the second highest Number of enrolments of both sexes of Secondary?
Give a very brief answer. 8.21e+04. What is the difference between the highest and the second highest Number of enrolments of both sexes in Secondary general?
Provide a short and direct response. 8.35e+04. What is the difference between the highest and the second highest Number of enrolments of both sexes in Secondary vocational?
Keep it short and to the point. 1069.15. What is the difference between the highest and the lowest Number of enrolments of both sexes of Primary?
Your answer should be compact. 2.87e+05. What is the difference between the highest and the lowest Number of enrolments of both sexes in Secondary?
Offer a very short reply. 2.87e+05. What is the difference between the highest and the lowest Number of enrolments of both sexes of Secondary general?
Ensure brevity in your answer.  2.91e+05. What is the difference between the highest and the lowest Number of enrolments of both sexes in Secondary vocational?
Your answer should be very brief. 6889.84. 